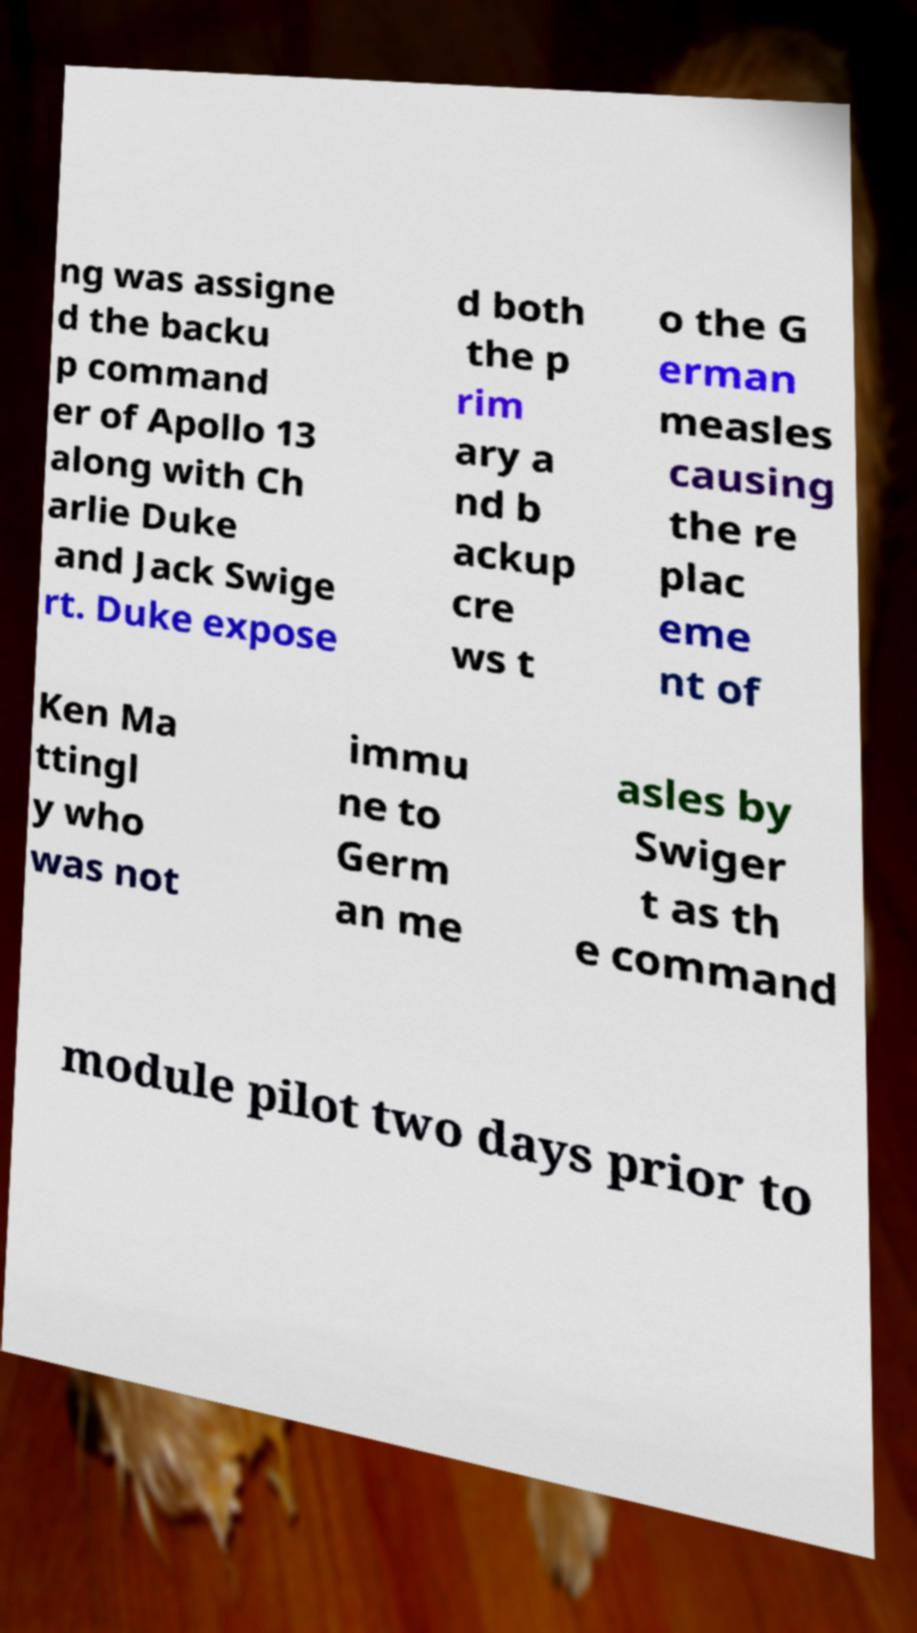There's text embedded in this image that I need extracted. Can you transcribe it verbatim? ng was assigne d the backu p command er of Apollo 13 along with Ch arlie Duke and Jack Swige rt. Duke expose d both the p rim ary a nd b ackup cre ws t o the G erman measles causing the re plac eme nt of Ken Ma ttingl y who was not immu ne to Germ an me asles by Swiger t as th e command module pilot two days prior to 